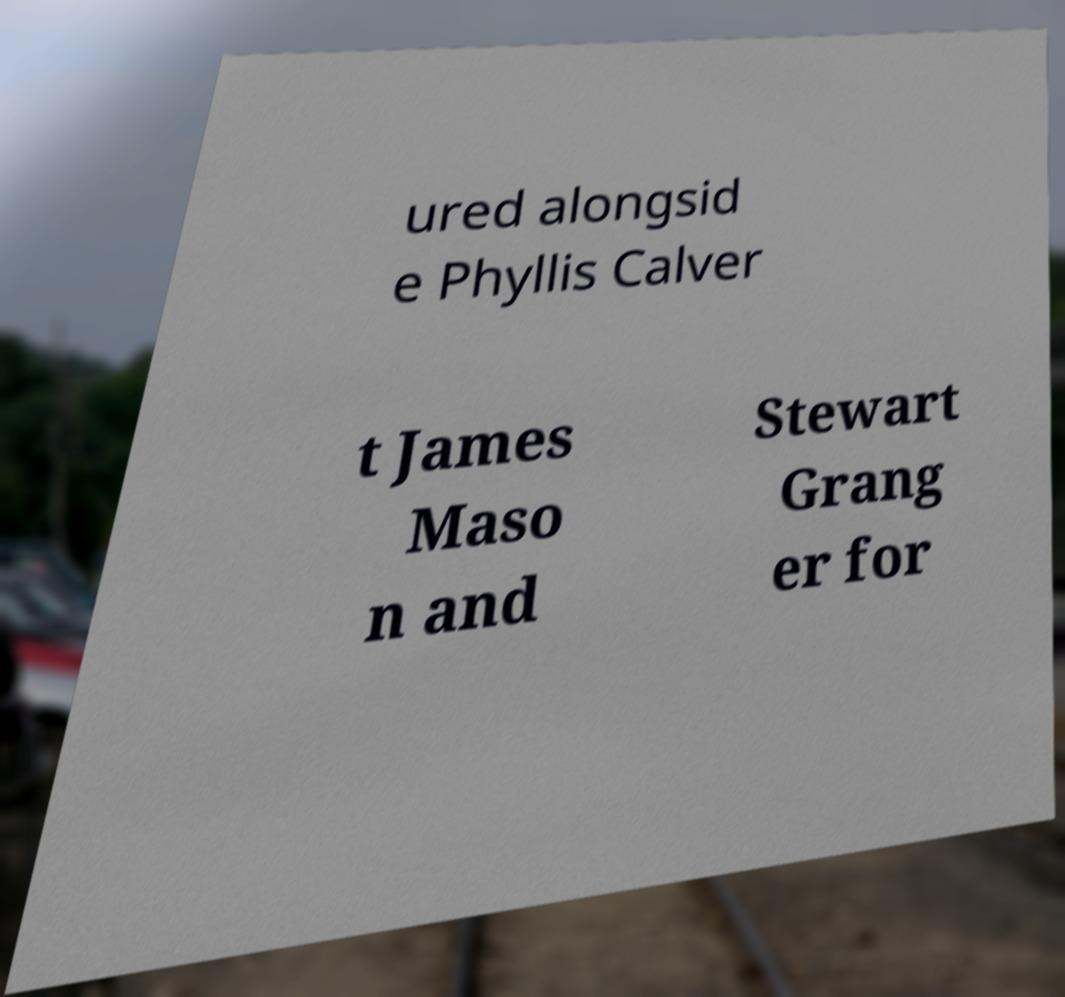I need the written content from this picture converted into text. Can you do that? ured alongsid e Phyllis Calver t James Maso n and Stewart Grang er for 